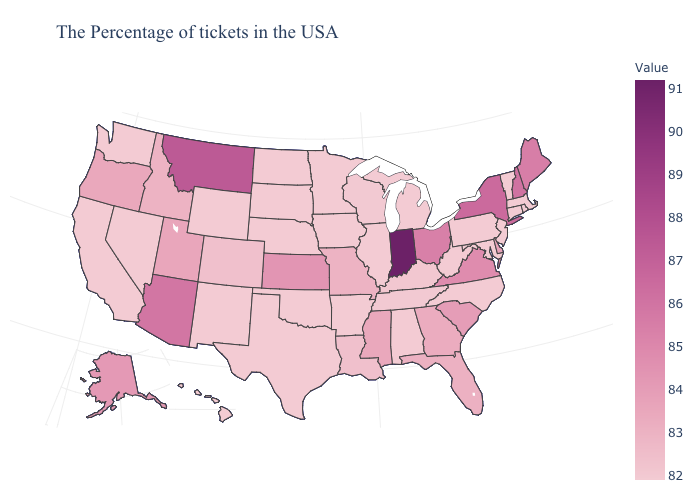Does Tennessee have the lowest value in the USA?
Be succinct. No. Which states have the lowest value in the USA?
Keep it brief. Massachusetts, Rhode Island, Vermont, Connecticut, New Jersey, Maryland, Pennsylvania, North Carolina, West Virginia, Michigan, Alabama, Illinois, Arkansas, Minnesota, Iowa, Nebraska, Oklahoma, Texas, South Dakota, North Dakota, Wyoming, New Mexico, Nevada, California, Washington, Hawaii. Which states hav the highest value in the South?
Short answer required. Virginia. Does Mississippi have the lowest value in the South?
Short answer required. No. Among the states that border Vermont , which have the lowest value?
Be succinct. Massachusetts. Does the map have missing data?
Be succinct. No. Among the states that border North Dakota , which have the lowest value?
Concise answer only. Minnesota, South Dakota. 